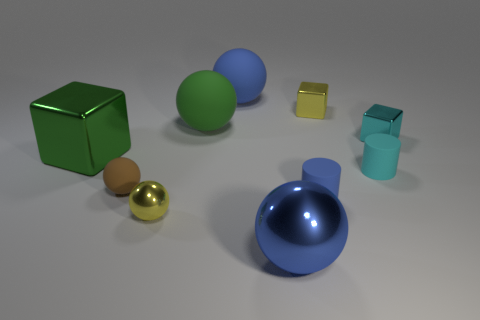Subtract all green spheres. How many spheres are left? 4 Subtract all large blue metallic balls. How many balls are left? 4 Subtract all cyan spheres. Subtract all purple cylinders. How many spheres are left? 5 Subtract all cubes. How many objects are left? 7 Add 4 green spheres. How many green spheres exist? 5 Subtract 0 red cylinders. How many objects are left? 10 Subtract all cyan objects. Subtract all cyan blocks. How many objects are left? 7 Add 1 yellow shiny spheres. How many yellow shiny spheres are left? 2 